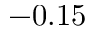Convert formula to latex. <formula><loc_0><loc_0><loc_500><loc_500>- 0 . 1 5</formula> 